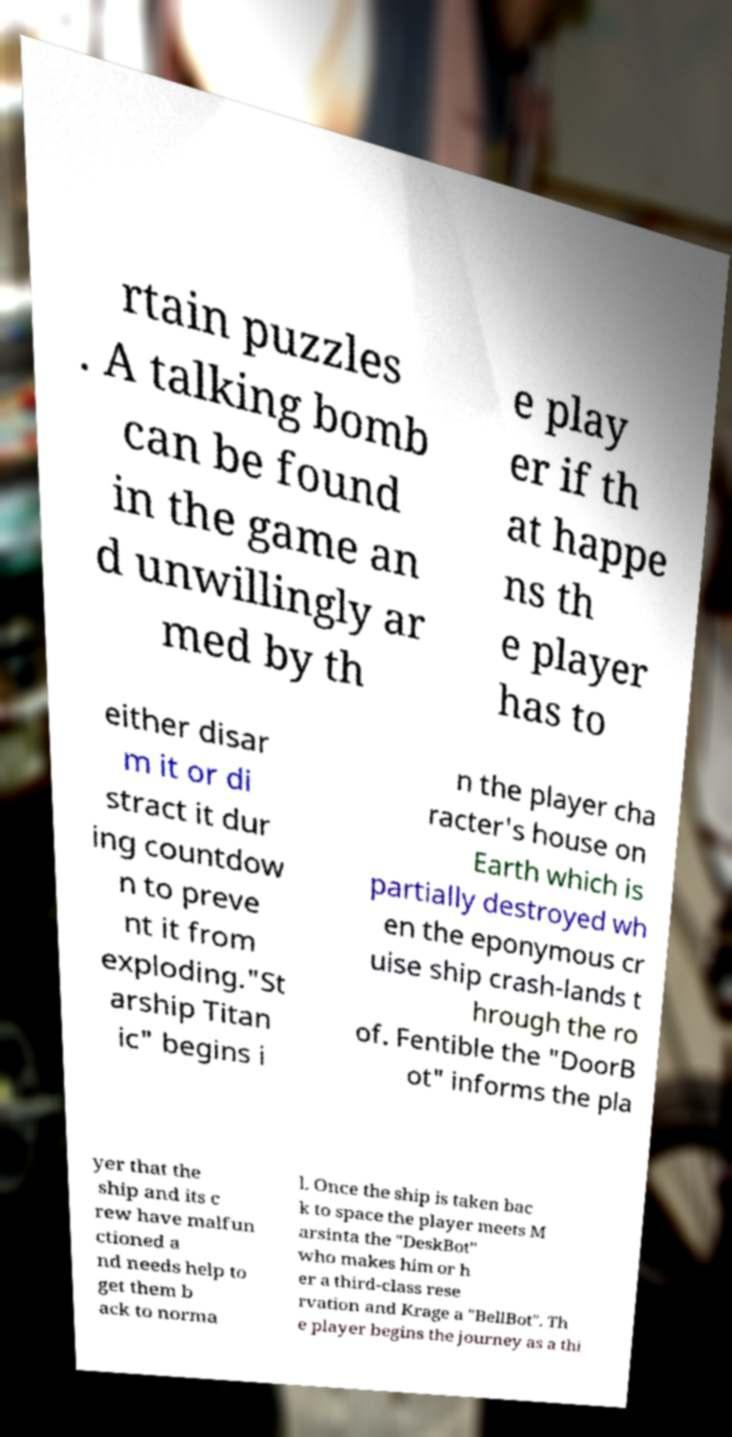Please read and relay the text visible in this image. What does it say? rtain puzzles . A talking bomb can be found in the game an d unwillingly ar med by th e play er if th at happe ns th e player has to either disar m it or di stract it dur ing countdow n to preve nt it from exploding."St arship Titan ic" begins i n the player cha racter's house on Earth which is partially destroyed wh en the eponymous cr uise ship crash-lands t hrough the ro of. Fentible the "DoorB ot" informs the pla yer that the ship and its c rew have malfun ctioned a nd needs help to get them b ack to norma l. Once the ship is taken bac k to space the player meets M arsinta the "DeskBot" who makes him or h er a third-class rese rvation and Krage a "BellBot". Th e player begins the journey as a thi 